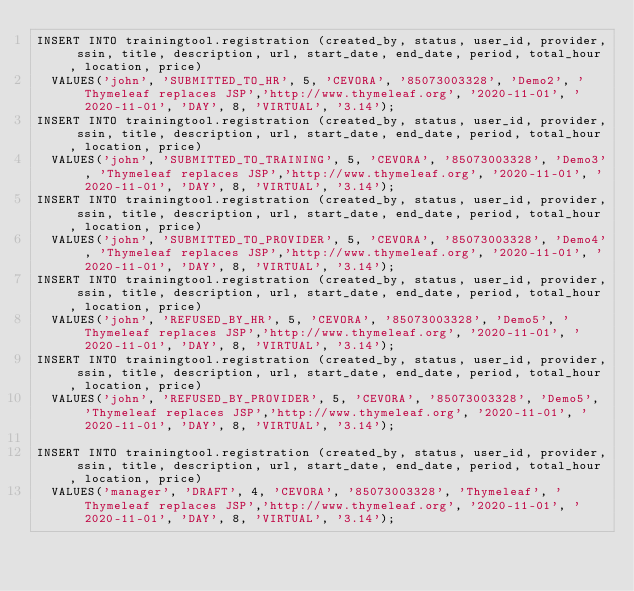<code> <loc_0><loc_0><loc_500><loc_500><_SQL_>INSERT INTO trainingtool.registration (created_by, status, user_id, provider, ssin, title, description, url, start_date, end_date, period, total_hour, location, price) 
	VALUES('john', 'SUBMITTED_TO_HR', 5, 'CEVORA', '85073003328', 'Demo2', 'Thymeleaf replaces JSP','http://www.thymeleaf.org', '2020-11-01', '2020-11-01', 'DAY', 8, 'VIRTUAL', '3.14');
INSERT INTO trainingtool.registration (created_by, status, user_id, provider, ssin, title, description, url, start_date, end_date, period, total_hour, location, price) 
	VALUES('john', 'SUBMITTED_TO_TRAINING', 5, 'CEVORA', '85073003328', 'Demo3', 'Thymeleaf replaces JSP','http://www.thymeleaf.org', '2020-11-01', '2020-11-01', 'DAY', 8, 'VIRTUAL', '3.14');
INSERT INTO trainingtool.registration (created_by, status, user_id, provider, ssin, title, description, url, start_date, end_date, period, total_hour, location, price) 
	VALUES('john', 'SUBMITTED_TO_PROVIDER', 5, 'CEVORA', '85073003328', 'Demo4', 'Thymeleaf replaces JSP','http://www.thymeleaf.org', '2020-11-01', '2020-11-01', 'DAY', 8, 'VIRTUAL', '3.14');
INSERT INTO trainingtool.registration (created_by, status, user_id, provider, ssin, title, description, url, start_date, end_date, period, total_hour, location, price) 
	VALUES('john', 'REFUSED_BY_HR', 5, 'CEVORA', '85073003328', 'Demo5', 'Thymeleaf replaces JSP','http://www.thymeleaf.org', '2020-11-01', '2020-11-01', 'DAY', 8, 'VIRTUAL', '3.14');
INSERT INTO trainingtool.registration (created_by, status, user_id, provider, ssin, title, description, url, start_date, end_date, period, total_hour, location, price) 
	VALUES('john', 'REFUSED_BY_PROVIDER', 5, 'CEVORA', '85073003328', 'Demo5', 'Thymeleaf replaces JSP','http://www.thymeleaf.org', '2020-11-01', '2020-11-01', 'DAY', 8, 'VIRTUAL', '3.14');

INSERT INTO trainingtool.registration (created_by, status, user_id, provider, ssin, title, description, url, start_date, end_date, period, total_hour, location, price) 
	VALUES('manager', 'DRAFT', 4, 'CEVORA', '85073003328', 'Thymeleaf', 'Thymeleaf replaces JSP','http://www.thymeleaf.org', '2020-11-01', '2020-11-01', 'DAY', 8, 'VIRTUAL', '3.14');
</code> 